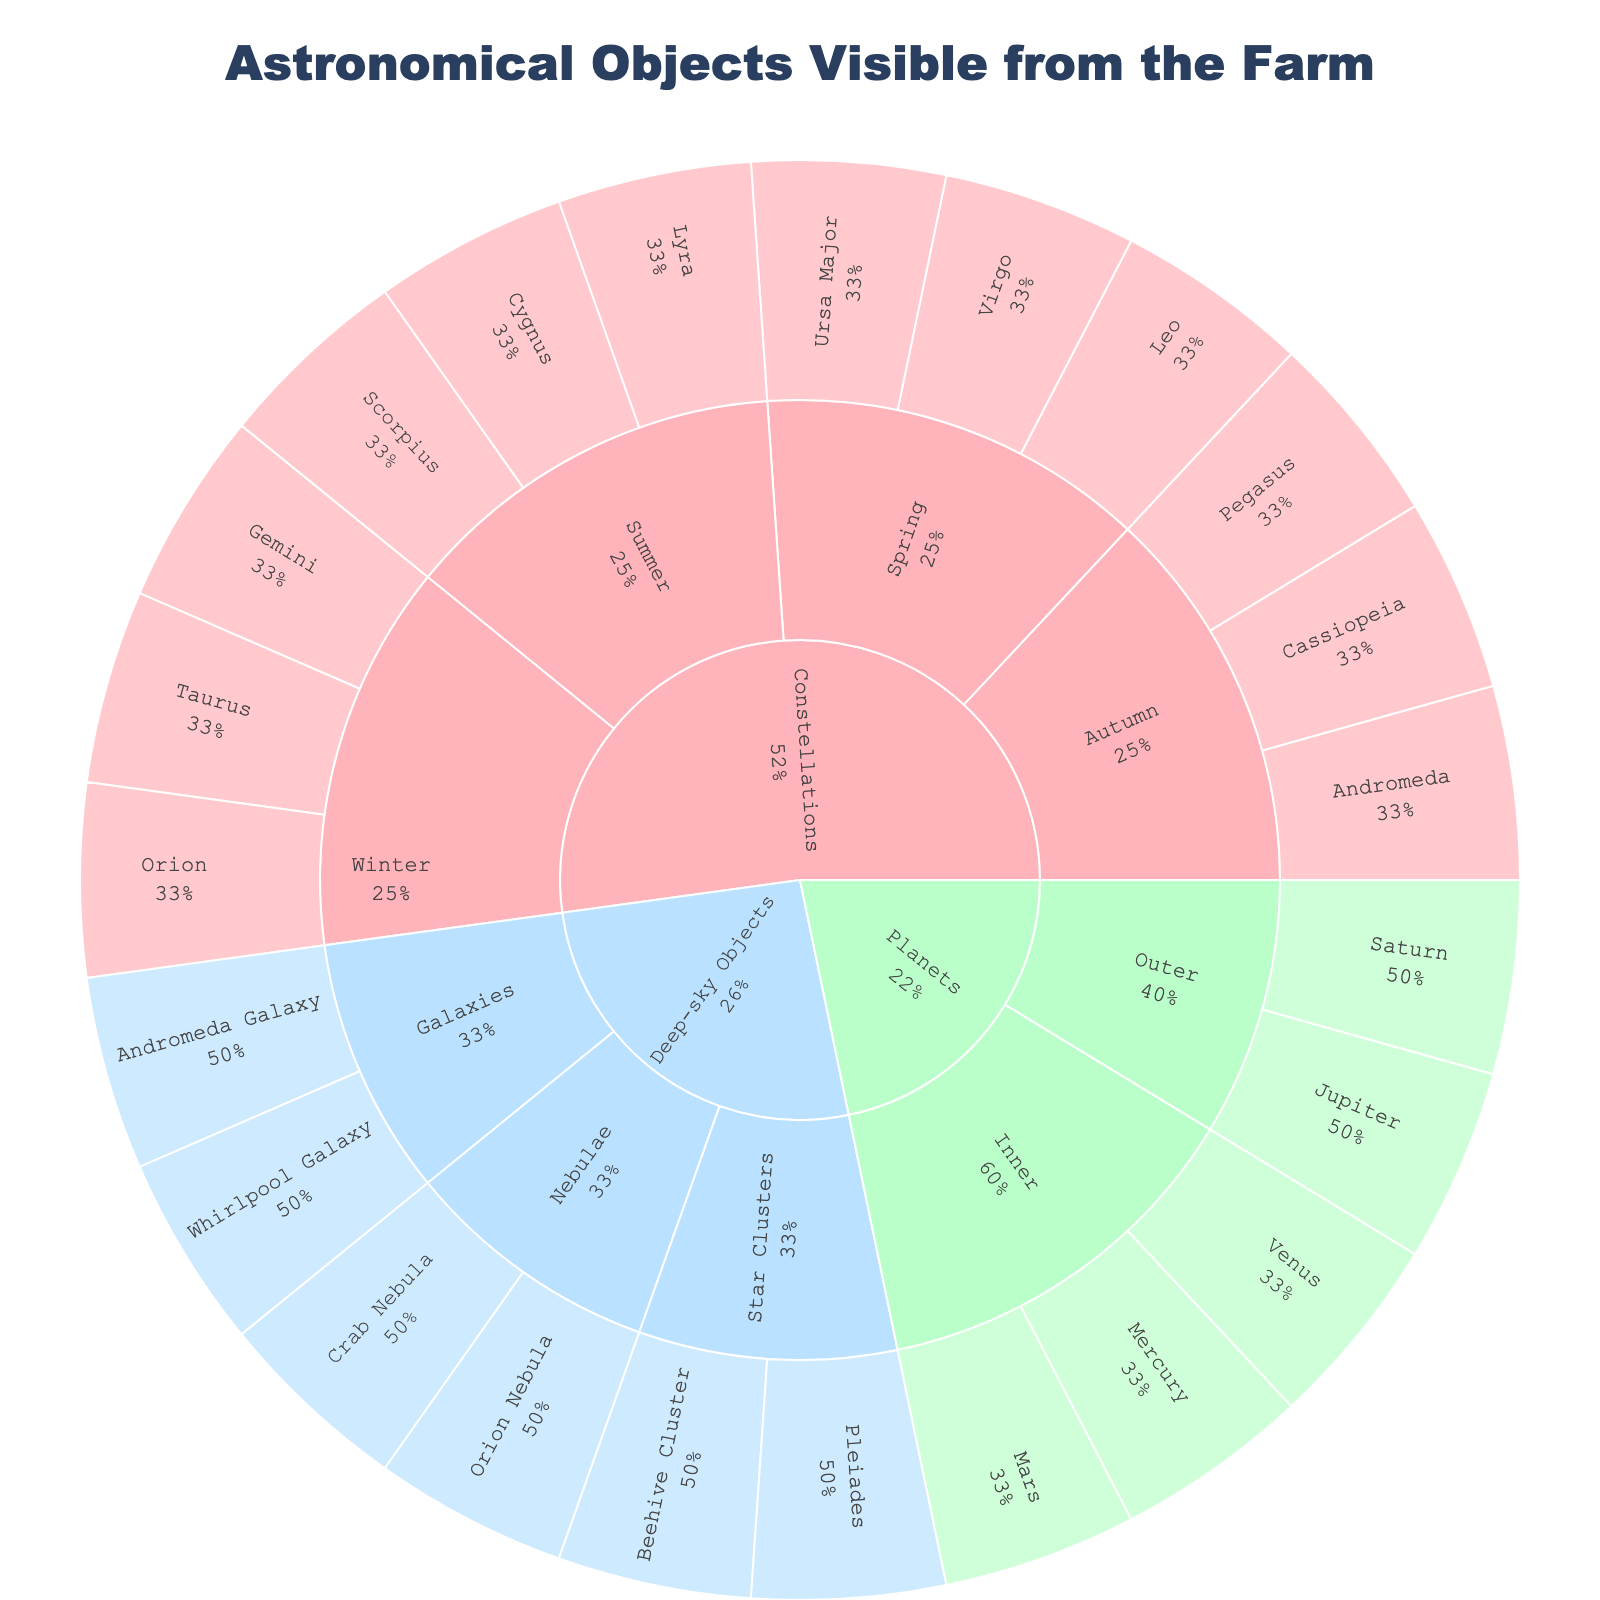What is the title of the Sunburst Plot? The title is usually displayed prominently at the top of the plot. It contextualizes the information presented. In this case, it states what the plot is about.
Answer: Astronomical Objects Visible from the Farm How many categories are there in the plot? Look at the first level of the Sunburst Plot rings. Each unique section at this level represents a different category.
Answer: 3 Which category has the highest number of subcategories? Count the number of subcategories within each category. Compare them to see which has the most.
Answer: Constellations How many objects are listed under 'Planets'? Navigate to the 'Planets' segment and count the number of objects listed within its sub-categories.
Answer: 5 During which season can you see the constellation 'Orion'? Follow the Sunburst Plot's path where 'Constellations' is the category, 'Winter' is the subcategory, and 'Orion' is listed as an object.
Answer: Winter Which category, between 'Constellations' and 'Deep-sky Objects', has more objects in total? Count the total number of objects listed under 'Constellations' and 'Deep-sky Objects'. Compare the totals.
Answer: Constellations What proportion of the objects under 'Planets' are in the 'Inner' subcategory? Identify the total number of objects in 'Planets' and then count those specifically under 'Inner'. Calculate the proportion (number in Inner / total).
Answer: 60% Which planet can be seen in both the 'Inner' and 'Outer' subcategories? Check the planets listed under both 'Inner' and 'Outer' subcategories to identify any overlaps.
Answer: None What percentage of the total objects does 'Deep-sky Objects' category represent? Sum up the total number of objects in all categories. Count the number of objects under 'Deep-sky Objects' and calculate the percentage (number in Deep-sky Objects / total).
Answer: 27.27% How many seasons feature three constellations visible from the farm? Examine each subcategory under 'Constellations' and count how many objects (constellations) are listed. Identify the seasons with exactly three objects.
Answer: 3 